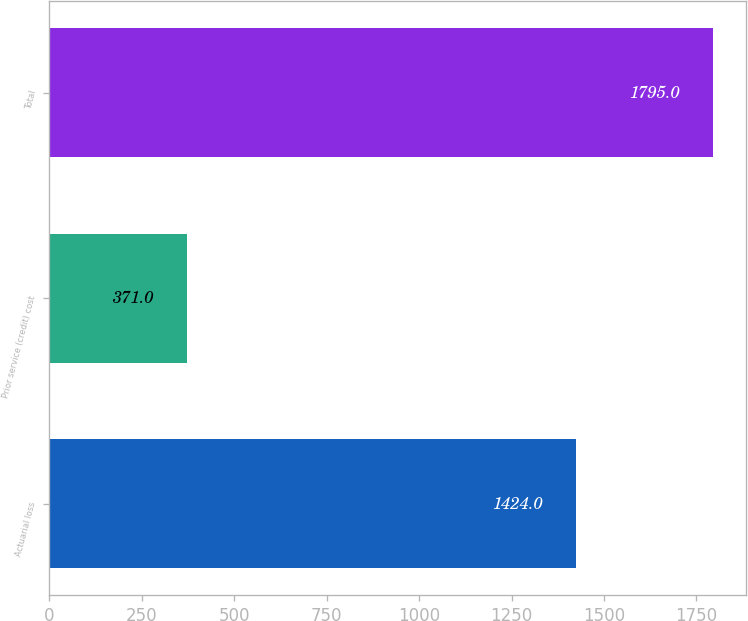<chart> <loc_0><loc_0><loc_500><loc_500><bar_chart><fcel>Actuarial loss<fcel>Prior service (credit) cost<fcel>Total<nl><fcel>1424<fcel>371<fcel>1795<nl></chart> 